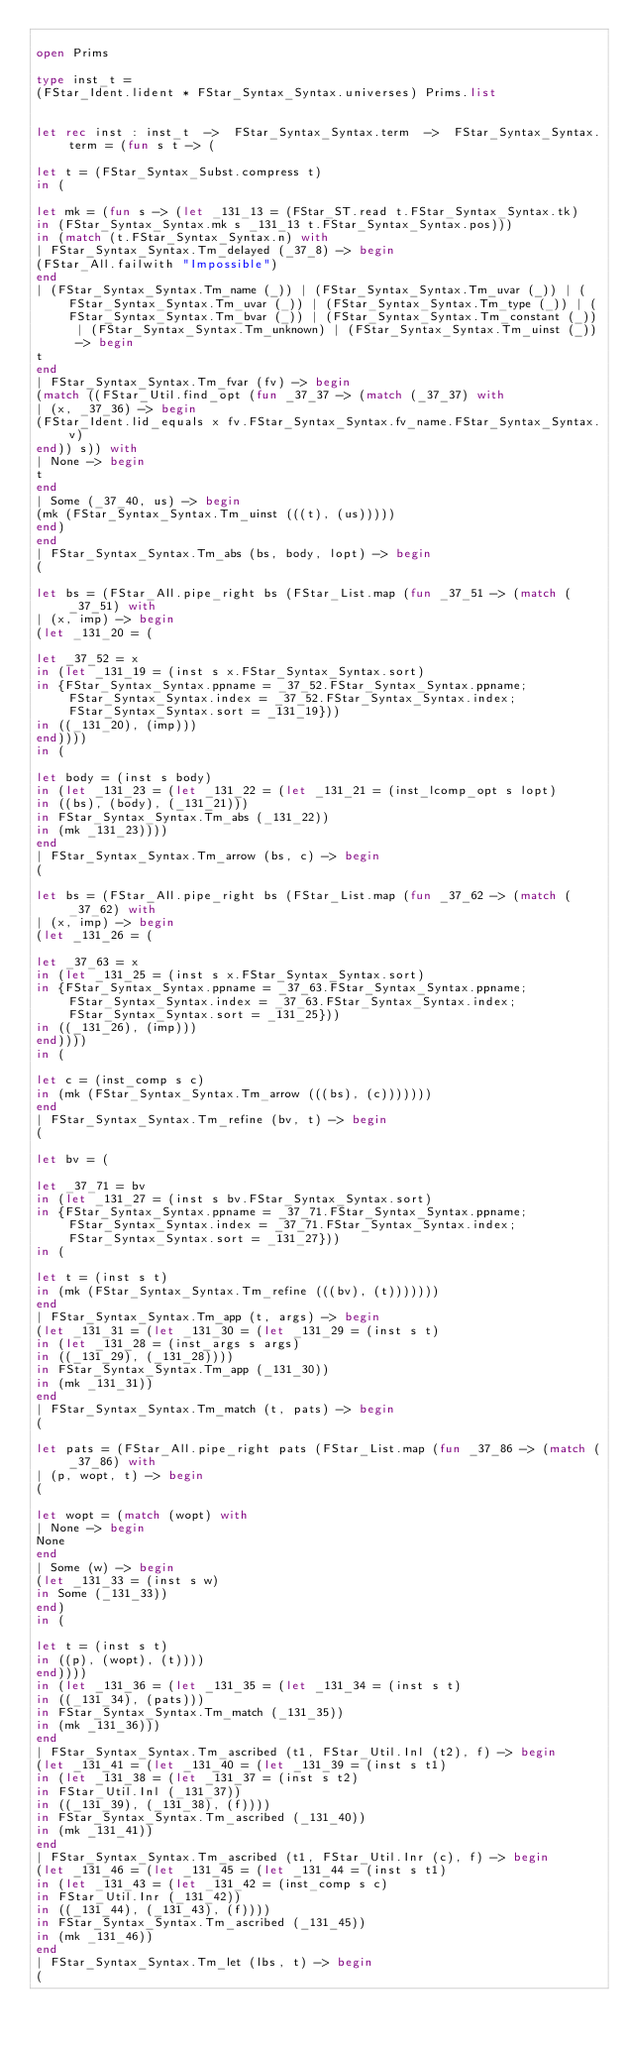Convert code to text. <code><loc_0><loc_0><loc_500><loc_500><_OCaml_>
open Prims

type inst_t =
(FStar_Ident.lident * FStar_Syntax_Syntax.universes) Prims.list


let rec inst : inst_t  ->  FStar_Syntax_Syntax.term  ->  FStar_Syntax_Syntax.term = (fun s t -> (

let t = (FStar_Syntax_Subst.compress t)
in (

let mk = (fun s -> (let _131_13 = (FStar_ST.read t.FStar_Syntax_Syntax.tk)
in (FStar_Syntax_Syntax.mk s _131_13 t.FStar_Syntax_Syntax.pos)))
in (match (t.FStar_Syntax_Syntax.n) with
| FStar_Syntax_Syntax.Tm_delayed (_37_8) -> begin
(FStar_All.failwith "Impossible")
end
| (FStar_Syntax_Syntax.Tm_name (_)) | (FStar_Syntax_Syntax.Tm_uvar (_)) | (FStar_Syntax_Syntax.Tm_uvar (_)) | (FStar_Syntax_Syntax.Tm_type (_)) | (FStar_Syntax_Syntax.Tm_bvar (_)) | (FStar_Syntax_Syntax.Tm_constant (_)) | (FStar_Syntax_Syntax.Tm_unknown) | (FStar_Syntax_Syntax.Tm_uinst (_)) -> begin
t
end
| FStar_Syntax_Syntax.Tm_fvar (fv) -> begin
(match ((FStar_Util.find_opt (fun _37_37 -> (match (_37_37) with
| (x, _37_36) -> begin
(FStar_Ident.lid_equals x fv.FStar_Syntax_Syntax.fv_name.FStar_Syntax_Syntax.v)
end)) s)) with
| None -> begin
t
end
| Some (_37_40, us) -> begin
(mk (FStar_Syntax_Syntax.Tm_uinst (((t), (us)))))
end)
end
| FStar_Syntax_Syntax.Tm_abs (bs, body, lopt) -> begin
(

let bs = (FStar_All.pipe_right bs (FStar_List.map (fun _37_51 -> (match (_37_51) with
| (x, imp) -> begin
(let _131_20 = (

let _37_52 = x
in (let _131_19 = (inst s x.FStar_Syntax_Syntax.sort)
in {FStar_Syntax_Syntax.ppname = _37_52.FStar_Syntax_Syntax.ppname; FStar_Syntax_Syntax.index = _37_52.FStar_Syntax_Syntax.index; FStar_Syntax_Syntax.sort = _131_19}))
in ((_131_20), (imp)))
end))))
in (

let body = (inst s body)
in (let _131_23 = (let _131_22 = (let _131_21 = (inst_lcomp_opt s lopt)
in ((bs), (body), (_131_21)))
in FStar_Syntax_Syntax.Tm_abs (_131_22))
in (mk _131_23))))
end
| FStar_Syntax_Syntax.Tm_arrow (bs, c) -> begin
(

let bs = (FStar_All.pipe_right bs (FStar_List.map (fun _37_62 -> (match (_37_62) with
| (x, imp) -> begin
(let _131_26 = (

let _37_63 = x
in (let _131_25 = (inst s x.FStar_Syntax_Syntax.sort)
in {FStar_Syntax_Syntax.ppname = _37_63.FStar_Syntax_Syntax.ppname; FStar_Syntax_Syntax.index = _37_63.FStar_Syntax_Syntax.index; FStar_Syntax_Syntax.sort = _131_25}))
in ((_131_26), (imp)))
end))))
in (

let c = (inst_comp s c)
in (mk (FStar_Syntax_Syntax.Tm_arrow (((bs), (c)))))))
end
| FStar_Syntax_Syntax.Tm_refine (bv, t) -> begin
(

let bv = (

let _37_71 = bv
in (let _131_27 = (inst s bv.FStar_Syntax_Syntax.sort)
in {FStar_Syntax_Syntax.ppname = _37_71.FStar_Syntax_Syntax.ppname; FStar_Syntax_Syntax.index = _37_71.FStar_Syntax_Syntax.index; FStar_Syntax_Syntax.sort = _131_27}))
in (

let t = (inst s t)
in (mk (FStar_Syntax_Syntax.Tm_refine (((bv), (t)))))))
end
| FStar_Syntax_Syntax.Tm_app (t, args) -> begin
(let _131_31 = (let _131_30 = (let _131_29 = (inst s t)
in (let _131_28 = (inst_args s args)
in ((_131_29), (_131_28))))
in FStar_Syntax_Syntax.Tm_app (_131_30))
in (mk _131_31))
end
| FStar_Syntax_Syntax.Tm_match (t, pats) -> begin
(

let pats = (FStar_All.pipe_right pats (FStar_List.map (fun _37_86 -> (match (_37_86) with
| (p, wopt, t) -> begin
(

let wopt = (match (wopt) with
| None -> begin
None
end
| Some (w) -> begin
(let _131_33 = (inst s w)
in Some (_131_33))
end)
in (

let t = (inst s t)
in ((p), (wopt), (t))))
end))))
in (let _131_36 = (let _131_35 = (let _131_34 = (inst s t)
in ((_131_34), (pats)))
in FStar_Syntax_Syntax.Tm_match (_131_35))
in (mk _131_36)))
end
| FStar_Syntax_Syntax.Tm_ascribed (t1, FStar_Util.Inl (t2), f) -> begin
(let _131_41 = (let _131_40 = (let _131_39 = (inst s t1)
in (let _131_38 = (let _131_37 = (inst s t2)
in FStar_Util.Inl (_131_37))
in ((_131_39), (_131_38), (f))))
in FStar_Syntax_Syntax.Tm_ascribed (_131_40))
in (mk _131_41))
end
| FStar_Syntax_Syntax.Tm_ascribed (t1, FStar_Util.Inr (c), f) -> begin
(let _131_46 = (let _131_45 = (let _131_44 = (inst s t1)
in (let _131_43 = (let _131_42 = (inst_comp s c)
in FStar_Util.Inr (_131_42))
in ((_131_44), (_131_43), (f))))
in FStar_Syntax_Syntax.Tm_ascribed (_131_45))
in (mk _131_46))
end
| FStar_Syntax_Syntax.Tm_let (lbs, t) -> begin
(
</code> 